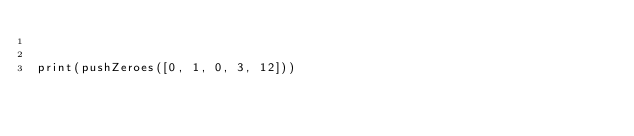<code> <loc_0><loc_0><loc_500><loc_500><_Python_>

print(pushZeroes([0, 1, 0, 3, 12]))
</code> 